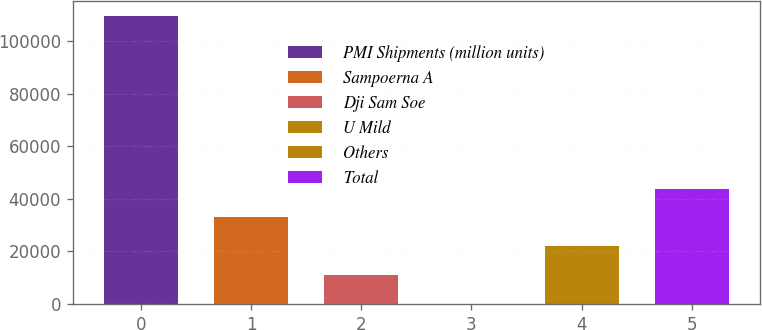Convert chart to OTSL. <chart><loc_0><loc_0><loc_500><loc_500><bar_chart><fcel>PMI Shipments (million units)<fcel>Sampoerna A<fcel>Dji Sam Soe<fcel>U Mild<fcel>Others<fcel>Total<nl><fcel>109694<fcel>32912<fcel>10974.3<fcel>5.4<fcel>21943.1<fcel>43880.8<nl></chart> 